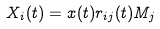<formula> <loc_0><loc_0><loc_500><loc_500>X _ { i } ( t ) = x ( t ) r _ { i j } ( t ) M _ { j }</formula> 